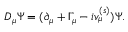<formula> <loc_0><loc_0><loc_500><loc_500>D _ { \mu } \Psi = ( \partial _ { \mu } + \Gamma _ { \mu } - i v _ { \mu } ^ { ( s ) } ) \Psi .</formula> 